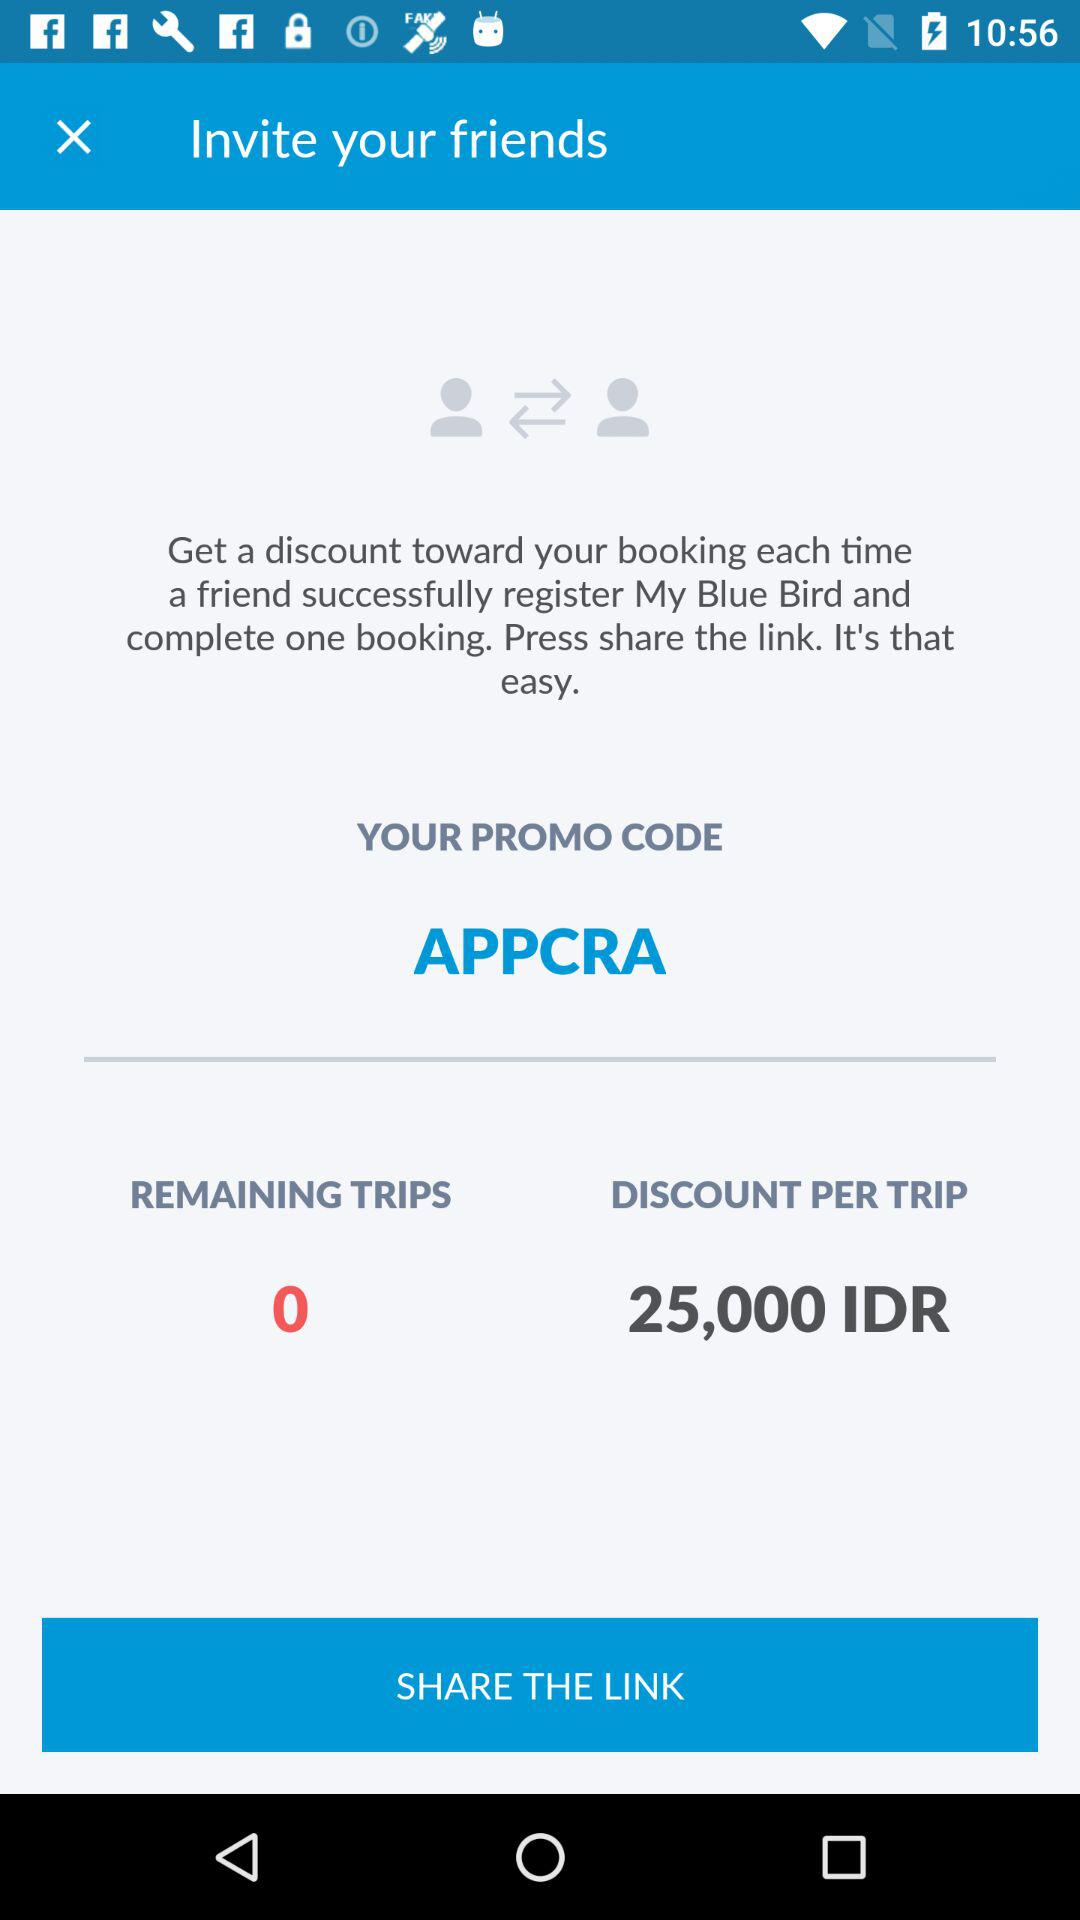How much is the discount per trip?
Answer the question using a single word or phrase. 25,000 IDR 